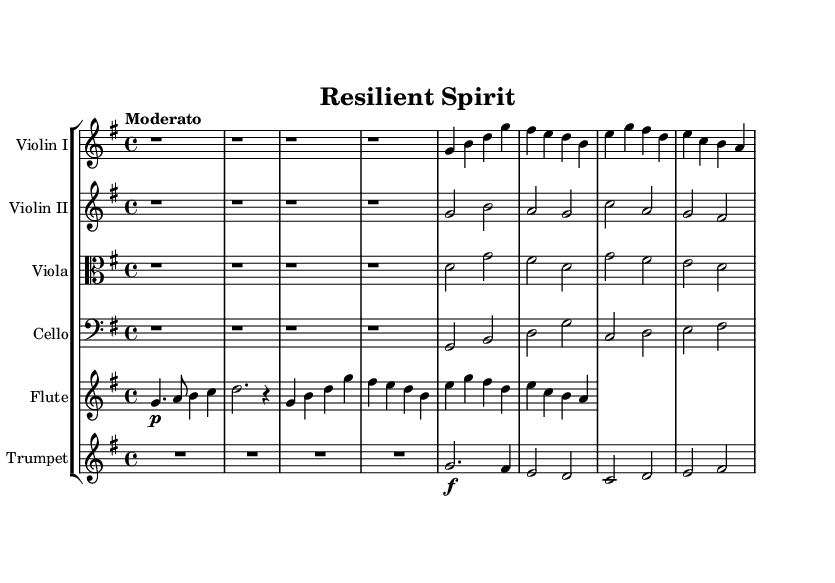What is the key signature of this music? The key signature is indicated by the number of sharps or flats at the beginning of the staff. Here, the G major key signature has one sharp, which is F sharp.
Answer: G major What is the time signature of this music? The time signature is found right after the key signature at the beginning of the score. In this case, it shows 4/4, meaning there are four beats in each measure and a quarter note gets one beat.
Answer: 4/4 What is the tempo marking for this piece? The tempo marking is provided at the beginning of the score, which states the recommended speed of the piece. Here, it shows "Moderato," indicating a moderate tempo.
Answer: Moderato How many sections does this symphony have? Looking at the score structure, we differentiate sections as theme A and theme B, along with an introduction. The score has one introduction and two main themes (A and B).
Answer: Three What is the highest instrument part in pitch? To determine the highest part, we can compare the written notes for the instruments. The flute part usually contains higher notes than strings. In this case, the flute starts at G4, which is the highest pitch compared to the other instruments.
Answer: Flute What dynamic marking is indicated for the trumpet in the theme? The dynamic marking for the trumpet in theme A is indicated with 'f,' which stands for forte. This signifies that the trumpet part should be played loudly.
Answer: Forte What are the thematic elements present in the composition? The score contains distinct theme A and theme B sections, which are different in melodic content and can be identified by specific note patterns. Each theme represents an aspect of the uplifting orchestral composition.
Answer: Two themes 